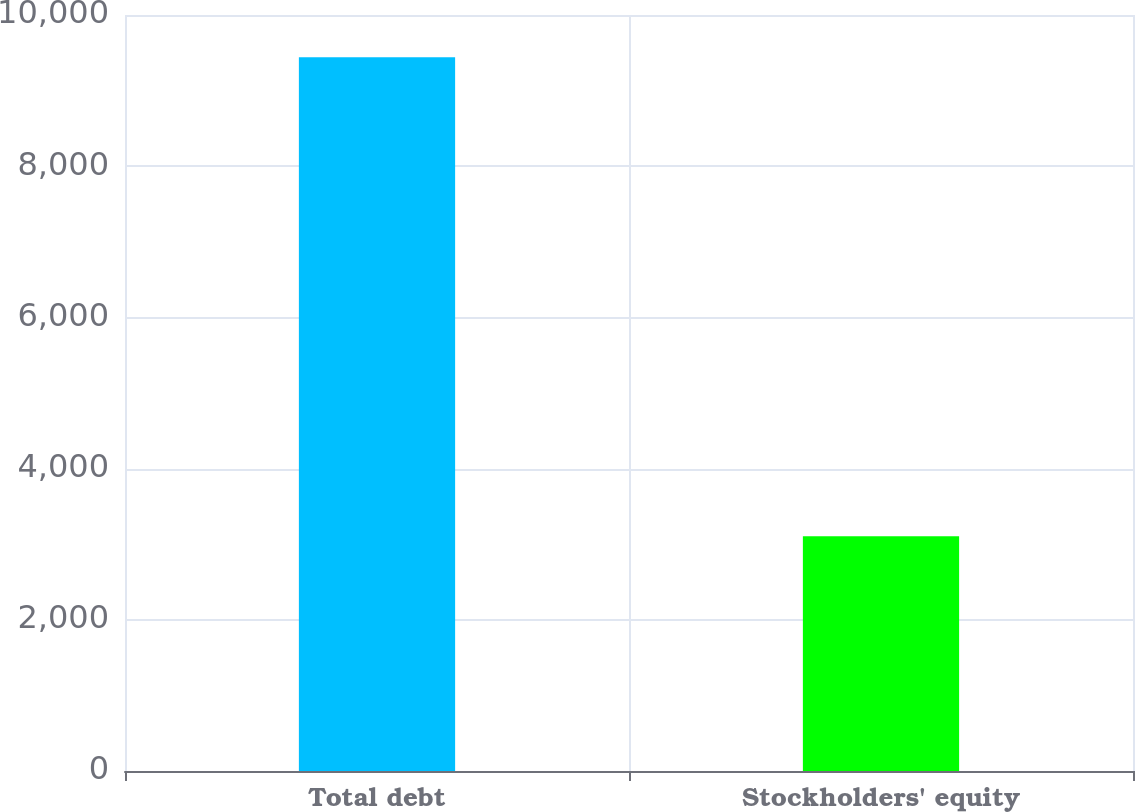Convert chart to OTSL. <chart><loc_0><loc_0><loc_500><loc_500><bar_chart><fcel>Total debt<fcel>Stockholders' equity<nl><fcel>9440<fcel>3106<nl></chart> 